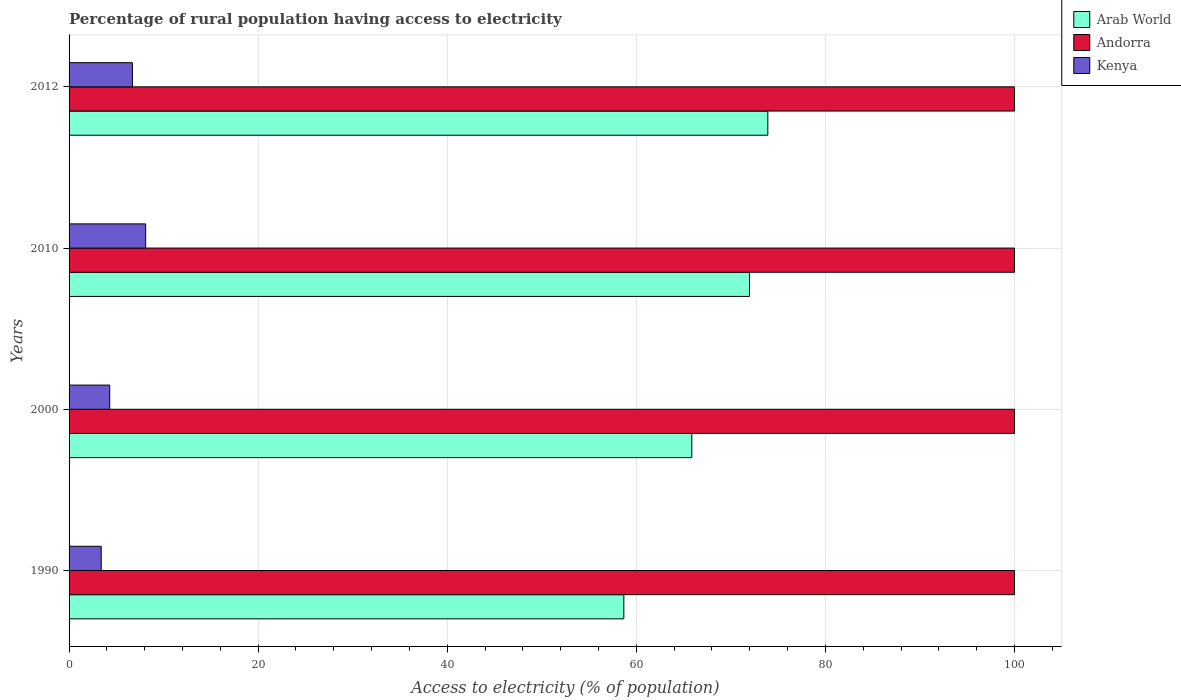How many groups of bars are there?
Provide a succinct answer. 4. Are the number of bars per tick equal to the number of legend labels?
Keep it short and to the point. Yes. What is the percentage of rural population having access to electricity in Arab World in 2000?
Make the answer very short. 65.87. Across all years, what is the maximum percentage of rural population having access to electricity in Arab World?
Your answer should be very brief. 73.91. In which year was the percentage of rural population having access to electricity in Kenya maximum?
Your response must be concise. 2010. In which year was the percentage of rural population having access to electricity in Kenya minimum?
Make the answer very short. 1990. What is the total percentage of rural population having access to electricity in Andorra in the graph?
Offer a very short reply. 400. What is the difference between the percentage of rural population having access to electricity in Andorra in 2010 and that in 2012?
Your answer should be compact. 0. What is the difference between the percentage of rural population having access to electricity in Arab World in 1990 and the percentage of rural population having access to electricity in Kenya in 2000?
Your answer should be very brief. 54.38. What is the average percentage of rural population having access to electricity in Arab World per year?
Ensure brevity in your answer.  67.61. In the year 1990, what is the difference between the percentage of rural population having access to electricity in Arab World and percentage of rural population having access to electricity in Kenya?
Your answer should be compact. 55.28. What is the ratio of the percentage of rural population having access to electricity in Arab World in 2000 to that in 2010?
Keep it short and to the point. 0.92. Is the percentage of rural population having access to electricity in Andorra in 1990 less than that in 2012?
Provide a succinct answer. No. Is the difference between the percentage of rural population having access to electricity in Arab World in 2010 and 2012 greater than the difference between the percentage of rural population having access to electricity in Kenya in 2010 and 2012?
Keep it short and to the point. No. What is the difference between the highest and the second highest percentage of rural population having access to electricity in Kenya?
Make the answer very short. 1.4. What is the difference between the highest and the lowest percentage of rural population having access to electricity in Kenya?
Make the answer very short. 4.7. What does the 1st bar from the top in 2012 represents?
Offer a terse response. Kenya. What does the 3rd bar from the bottom in 2000 represents?
Your response must be concise. Kenya. Are the values on the major ticks of X-axis written in scientific E-notation?
Your answer should be very brief. No. Does the graph contain any zero values?
Give a very brief answer. No. Does the graph contain grids?
Provide a succinct answer. Yes. How are the legend labels stacked?
Offer a terse response. Vertical. What is the title of the graph?
Offer a terse response. Percentage of rural population having access to electricity. Does "Guyana" appear as one of the legend labels in the graph?
Provide a short and direct response. No. What is the label or title of the X-axis?
Provide a short and direct response. Access to electricity (% of population). What is the label or title of the Y-axis?
Your answer should be very brief. Years. What is the Access to electricity (% of population) in Arab World in 1990?
Offer a terse response. 58.68. What is the Access to electricity (% of population) of Andorra in 1990?
Offer a very short reply. 100. What is the Access to electricity (% of population) in Arab World in 2000?
Keep it short and to the point. 65.87. What is the Access to electricity (% of population) of Arab World in 2010?
Keep it short and to the point. 71.97. What is the Access to electricity (% of population) in Andorra in 2010?
Offer a very short reply. 100. What is the Access to electricity (% of population) of Arab World in 2012?
Provide a short and direct response. 73.91. What is the Access to electricity (% of population) in Andorra in 2012?
Make the answer very short. 100. Across all years, what is the maximum Access to electricity (% of population) in Arab World?
Make the answer very short. 73.91. Across all years, what is the minimum Access to electricity (% of population) in Arab World?
Make the answer very short. 58.68. Across all years, what is the minimum Access to electricity (% of population) in Andorra?
Provide a succinct answer. 100. Across all years, what is the minimum Access to electricity (% of population) of Kenya?
Your response must be concise. 3.4. What is the total Access to electricity (% of population) of Arab World in the graph?
Provide a short and direct response. 270.43. What is the total Access to electricity (% of population) of Andorra in the graph?
Make the answer very short. 400. What is the difference between the Access to electricity (% of population) of Arab World in 1990 and that in 2000?
Give a very brief answer. -7.19. What is the difference between the Access to electricity (% of population) in Andorra in 1990 and that in 2000?
Offer a very short reply. 0. What is the difference between the Access to electricity (% of population) in Arab World in 1990 and that in 2010?
Provide a short and direct response. -13.29. What is the difference between the Access to electricity (% of population) of Andorra in 1990 and that in 2010?
Make the answer very short. 0. What is the difference between the Access to electricity (% of population) of Kenya in 1990 and that in 2010?
Your answer should be very brief. -4.7. What is the difference between the Access to electricity (% of population) in Arab World in 1990 and that in 2012?
Your answer should be compact. -15.23. What is the difference between the Access to electricity (% of population) in Kenya in 1990 and that in 2012?
Your answer should be very brief. -3.3. What is the difference between the Access to electricity (% of population) of Arab World in 2000 and that in 2010?
Ensure brevity in your answer.  -6.1. What is the difference between the Access to electricity (% of population) in Kenya in 2000 and that in 2010?
Your answer should be compact. -3.8. What is the difference between the Access to electricity (% of population) of Arab World in 2000 and that in 2012?
Provide a short and direct response. -8.04. What is the difference between the Access to electricity (% of population) of Arab World in 2010 and that in 2012?
Provide a succinct answer. -1.94. What is the difference between the Access to electricity (% of population) in Arab World in 1990 and the Access to electricity (% of population) in Andorra in 2000?
Offer a very short reply. -41.32. What is the difference between the Access to electricity (% of population) in Arab World in 1990 and the Access to electricity (% of population) in Kenya in 2000?
Your answer should be very brief. 54.38. What is the difference between the Access to electricity (% of population) in Andorra in 1990 and the Access to electricity (% of population) in Kenya in 2000?
Offer a terse response. 95.7. What is the difference between the Access to electricity (% of population) of Arab World in 1990 and the Access to electricity (% of population) of Andorra in 2010?
Make the answer very short. -41.32. What is the difference between the Access to electricity (% of population) in Arab World in 1990 and the Access to electricity (% of population) in Kenya in 2010?
Offer a very short reply. 50.58. What is the difference between the Access to electricity (% of population) of Andorra in 1990 and the Access to electricity (% of population) of Kenya in 2010?
Offer a terse response. 91.9. What is the difference between the Access to electricity (% of population) in Arab World in 1990 and the Access to electricity (% of population) in Andorra in 2012?
Your answer should be compact. -41.32. What is the difference between the Access to electricity (% of population) of Arab World in 1990 and the Access to electricity (% of population) of Kenya in 2012?
Ensure brevity in your answer.  51.98. What is the difference between the Access to electricity (% of population) of Andorra in 1990 and the Access to electricity (% of population) of Kenya in 2012?
Your response must be concise. 93.3. What is the difference between the Access to electricity (% of population) in Arab World in 2000 and the Access to electricity (% of population) in Andorra in 2010?
Offer a terse response. -34.13. What is the difference between the Access to electricity (% of population) of Arab World in 2000 and the Access to electricity (% of population) of Kenya in 2010?
Provide a succinct answer. 57.77. What is the difference between the Access to electricity (% of population) in Andorra in 2000 and the Access to electricity (% of population) in Kenya in 2010?
Give a very brief answer. 91.9. What is the difference between the Access to electricity (% of population) of Arab World in 2000 and the Access to electricity (% of population) of Andorra in 2012?
Offer a terse response. -34.13. What is the difference between the Access to electricity (% of population) in Arab World in 2000 and the Access to electricity (% of population) in Kenya in 2012?
Your answer should be very brief. 59.17. What is the difference between the Access to electricity (% of population) of Andorra in 2000 and the Access to electricity (% of population) of Kenya in 2012?
Ensure brevity in your answer.  93.3. What is the difference between the Access to electricity (% of population) in Arab World in 2010 and the Access to electricity (% of population) in Andorra in 2012?
Your answer should be compact. -28.03. What is the difference between the Access to electricity (% of population) in Arab World in 2010 and the Access to electricity (% of population) in Kenya in 2012?
Your response must be concise. 65.27. What is the difference between the Access to electricity (% of population) in Andorra in 2010 and the Access to electricity (% of population) in Kenya in 2012?
Give a very brief answer. 93.3. What is the average Access to electricity (% of population) of Arab World per year?
Ensure brevity in your answer.  67.61. What is the average Access to electricity (% of population) in Kenya per year?
Keep it short and to the point. 5.62. In the year 1990, what is the difference between the Access to electricity (% of population) in Arab World and Access to electricity (% of population) in Andorra?
Your response must be concise. -41.32. In the year 1990, what is the difference between the Access to electricity (% of population) in Arab World and Access to electricity (% of population) in Kenya?
Give a very brief answer. 55.28. In the year 1990, what is the difference between the Access to electricity (% of population) in Andorra and Access to electricity (% of population) in Kenya?
Your answer should be compact. 96.6. In the year 2000, what is the difference between the Access to electricity (% of population) in Arab World and Access to electricity (% of population) in Andorra?
Ensure brevity in your answer.  -34.13. In the year 2000, what is the difference between the Access to electricity (% of population) of Arab World and Access to electricity (% of population) of Kenya?
Ensure brevity in your answer.  61.57. In the year 2000, what is the difference between the Access to electricity (% of population) of Andorra and Access to electricity (% of population) of Kenya?
Your response must be concise. 95.7. In the year 2010, what is the difference between the Access to electricity (% of population) of Arab World and Access to electricity (% of population) of Andorra?
Provide a succinct answer. -28.03. In the year 2010, what is the difference between the Access to electricity (% of population) in Arab World and Access to electricity (% of population) in Kenya?
Provide a succinct answer. 63.87. In the year 2010, what is the difference between the Access to electricity (% of population) of Andorra and Access to electricity (% of population) of Kenya?
Your answer should be compact. 91.9. In the year 2012, what is the difference between the Access to electricity (% of population) in Arab World and Access to electricity (% of population) in Andorra?
Keep it short and to the point. -26.09. In the year 2012, what is the difference between the Access to electricity (% of population) of Arab World and Access to electricity (% of population) of Kenya?
Your response must be concise. 67.21. In the year 2012, what is the difference between the Access to electricity (% of population) in Andorra and Access to electricity (% of population) in Kenya?
Your response must be concise. 93.3. What is the ratio of the Access to electricity (% of population) in Arab World in 1990 to that in 2000?
Your answer should be compact. 0.89. What is the ratio of the Access to electricity (% of population) in Kenya in 1990 to that in 2000?
Provide a succinct answer. 0.79. What is the ratio of the Access to electricity (% of population) in Arab World in 1990 to that in 2010?
Offer a terse response. 0.82. What is the ratio of the Access to electricity (% of population) of Andorra in 1990 to that in 2010?
Your answer should be compact. 1. What is the ratio of the Access to electricity (% of population) in Kenya in 1990 to that in 2010?
Ensure brevity in your answer.  0.42. What is the ratio of the Access to electricity (% of population) in Arab World in 1990 to that in 2012?
Ensure brevity in your answer.  0.79. What is the ratio of the Access to electricity (% of population) of Kenya in 1990 to that in 2012?
Provide a short and direct response. 0.51. What is the ratio of the Access to electricity (% of population) in Arab World in 2000 to that in 2010?
Give a very brief answer. 0.92. What is the ratio of the Access to electricity (% of population) in Kenya in 2000 to that in 2010?
Provide a succinct answer. 0.53. What is the ratio of the Access to electricity (% of population) in Arab World in 2000 to that in 2012?
Your answer should be compact. 0.89. What is the ratio of the Access to electricity (% of population) of Andorra in 2000 to that in 2012?
Keep it short and to the point. 1. What is the ratio of the Access to electricity (% of population) of Kenya in 2000 to that in 2012?
Make the answer very short. 0.64. What is the ratio of the Access to electricity (% of population) of Arab World in 2010 to that in 2012?
Ensure brevity in your answer.  0.97. What is the ratio of the Access to electricity (% of population) of Kenya in 2010 to that in 2012?
Ensure brevity in your answer.  1.21. What is the difference between the highest and the second highest Access to electricity (% of population) in Arab World?
Provide a short and direct response. 1.94. What is the difference between the highest and the second highest Access to electricity (% of population) in Kenya?
Keep it short and to the point. 1.4. What is the difference between the highest and the lowest Access to electricity (% of population) of Arab World?
Keep it short and to the point. 15.23. What is the difference between the highest and the lowest Access to electricity (% of population) of Andorra?
Your answer should be compact. 0. 